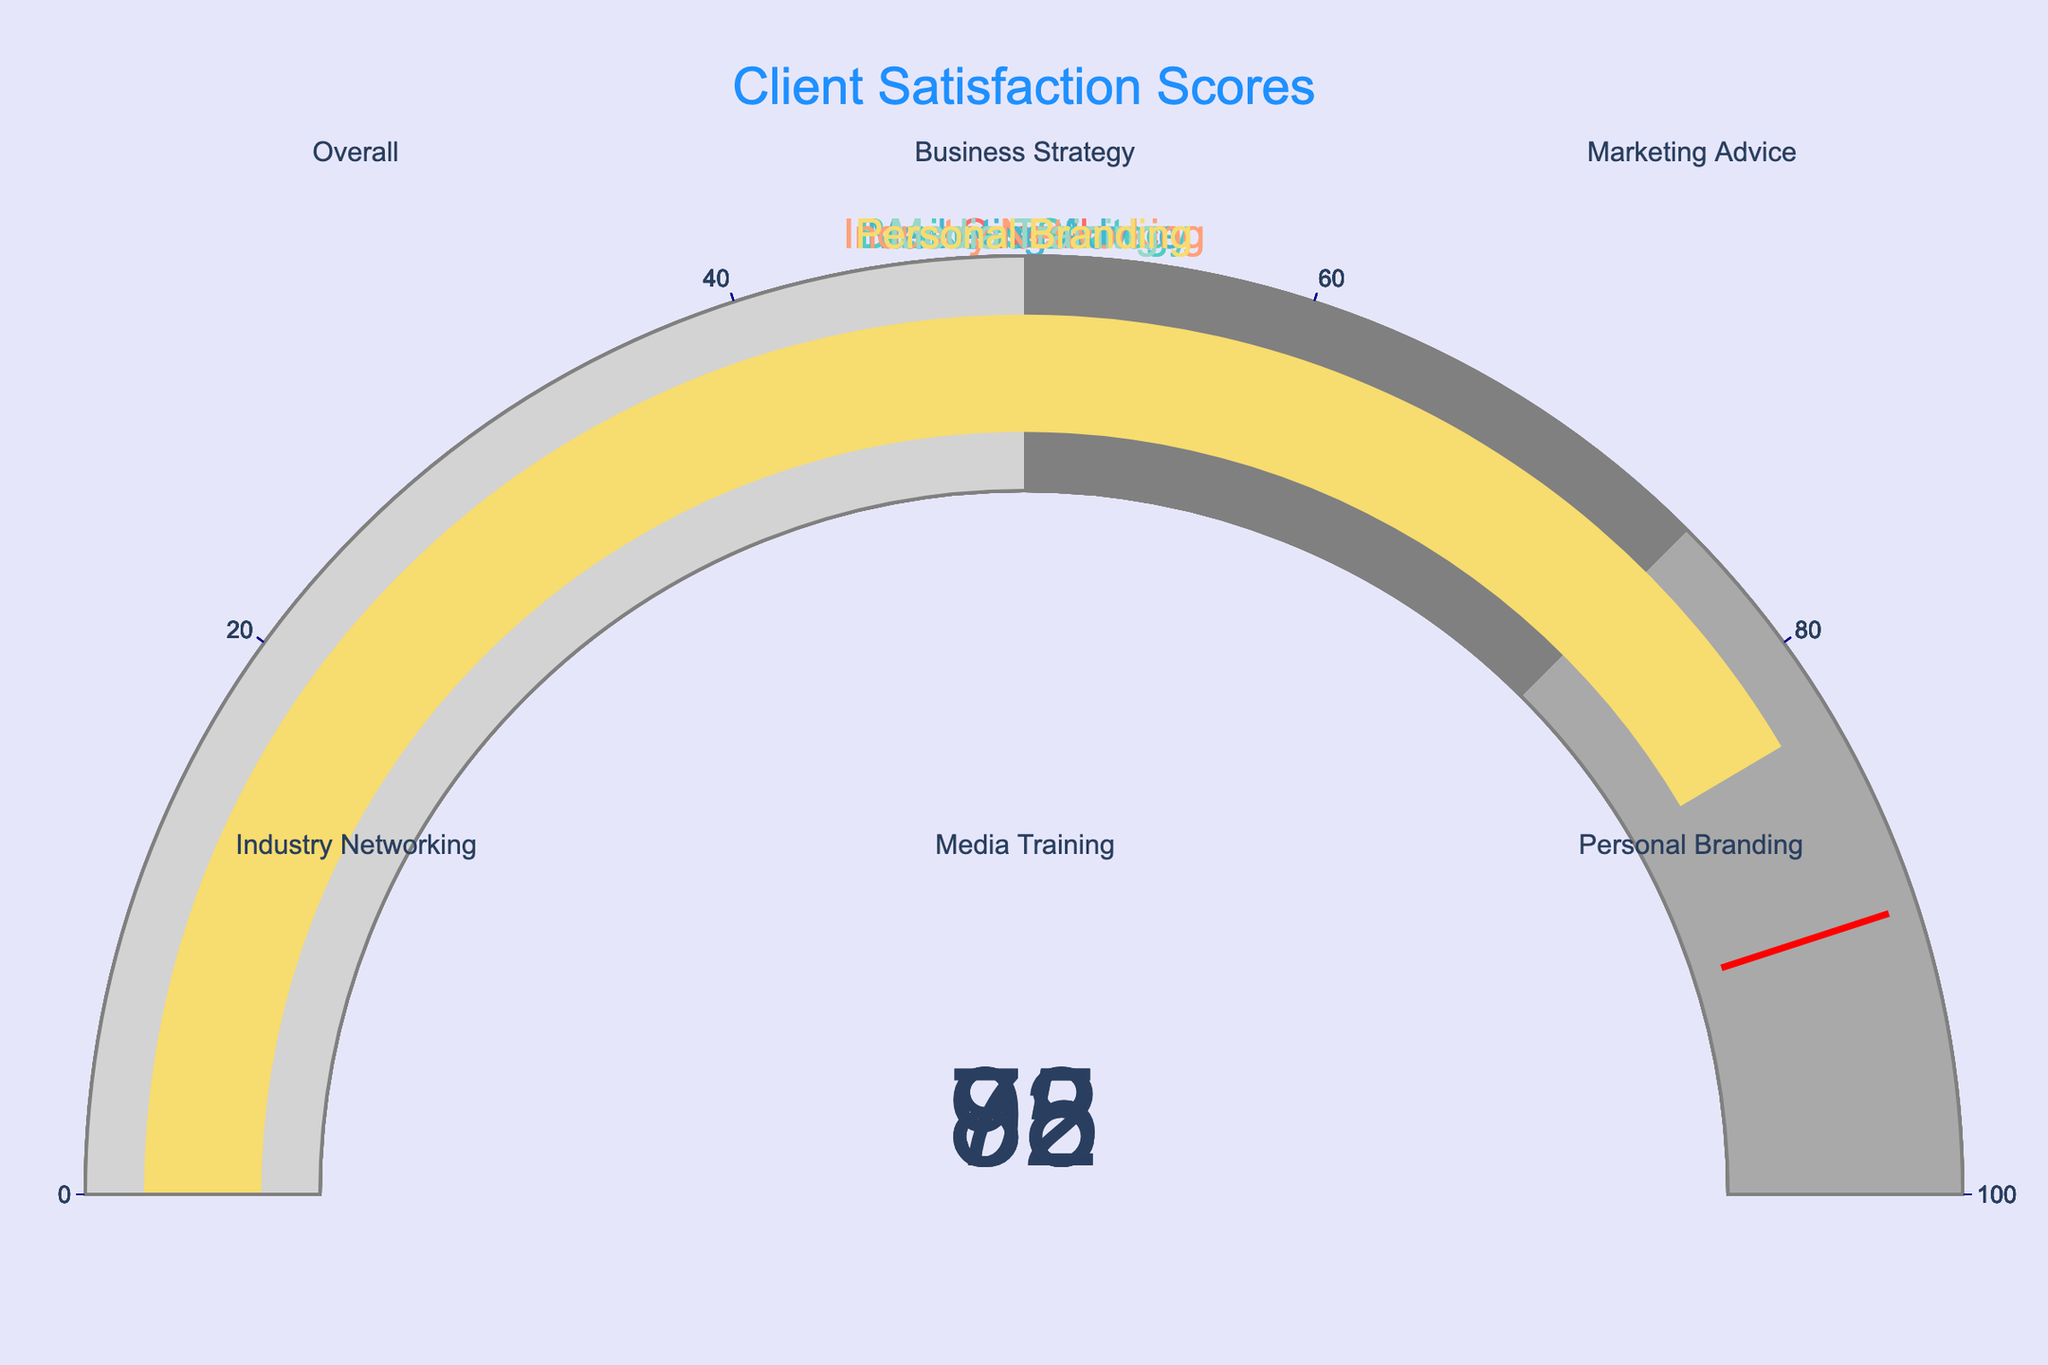What's the highest satisfaction score? The gauge chart with the highest value represents the highest satisfaction score. From the figure, 'Media Training' has a satisfaction score of 95, which is the highest.
Answer: 95 Which area has the lowest satisfaction score? To find the lowest satisfaction score, we need to identify the gauge chart with the lowest value. 'Marketing Advice' shows a satisfaction score of 78, which is the lowest among all areas.
Answer: 78 What is the overall satisfaction score? The gauge specifically labeled 'Overall' shows the overall satisfaction score. By examining the figure, the 'Overall' gauge indicates a score of 85.
Answer: 85 How much higher is the satisfaction score for 'Business Strategy' compared to 'Personal Branding'? The satisfaction score for 'Business Strategy' is 92, and for 'Personal Branding' it is 83. The difference is calculated by subtracting 83 from 92.
Answer: 92 - 83 = 9 Estimate the average satisfaction score across all areas. The satisfaction scores are 85, 92, 78, 88, 95, and 83. Adding these values gives 521. Dividing by the number of areas (6) gives the average: 521 / 6 ≈ 86.83.
Answer: ≈ 86.83 Which satisfaction score is closest to 90? By examining the charts, the scores are 85, 92, 78, 88, 95, and 83. The closest value to 90 is 88 for 'Industry Networking'.
Answer: 88 Are any of the satisfaction scores above 90? The gauge charts for 'Business Strategy' and 'Media Training' show scores of 92 and 95 respectively, both of which are above 90.
Answer: Yes What is the difference between the highest and lowest satisfaction scores? The highest score is 95 (Media Training) and the lowest is 78 (Marketing Advice). The difference is 95 - 78.
Answer: 95 - 78 = 17 Which area has a satisfaction score closest to the overall score? The overall score is 85. Comparing other scores (92, 78, 88, 95, 83), the closest score to 85 is 83 for 'Personal Branding'.
Answer: 83 What colors are used in the gauge charts? The gauge charts use specific colors for each client. The colors visible in the gauge charts are shades of red, teal, blue, salmon, mint, and yellow.
Answer: Red, teal, blue, salmon, mint, yellow 